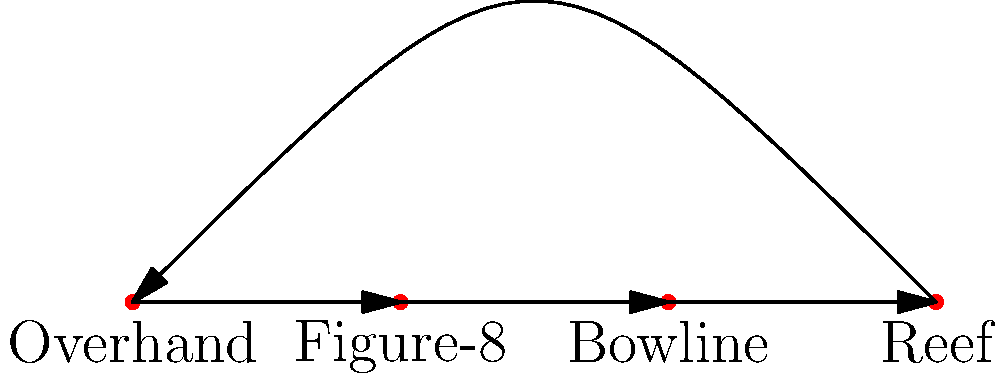In traditional Chinese crafts, various knots are used for different purposes. The diagram shows a simplified topological representation of four common knots: Overhand, Figure-8, Bowline, and Reef. Which of these knots is considered the most complex in terms of its topological structure, and why? To determine the most complex knot in terms of topological structure, we need to consider the following steps:

1. Examine the diagram: The diagram shows four knots arranged in a circular pattern, with arrows indicating the transformation from one knot to another.

2. Understand knot complexity: In topology, knot complexity is often related to the number of crossings and the difficulty in untying the knot.

3. Analyze each knot:
   a) Overhand knot: The simplest knot with only one crossing.
   b) Figure-8 knot: More complex than the overhand knot, with two crossings.
   c) Bowline knot: A loop knot that is more complex than the figure-8, with three crossings.
   d) Reef knot: Also known as a square knot, it has four crossings.

4. Consider historical context: In traditional Chinese crafts, the complexity of knots often represents symbolism and artistic value.

5. Conclusion: Among the given knots, the Reef knot (square knot) is the most complex topologically due to its four crossings and its significance in Chinese decorative knotting.
Answer: Reef knot 